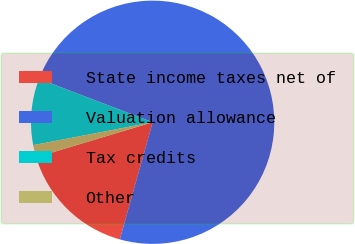Convert chart. <chart><loc_0><loc_0><loc_500><loc_500><pie_chart><fcel>State income taxes net of<fcel>Valuation allowance<fcel>Tax credits<fcel>Other<nl><fcel>16.01%<fcel>73.54%<fcel>8.82%<fcel>1.63%<nl></chart> 